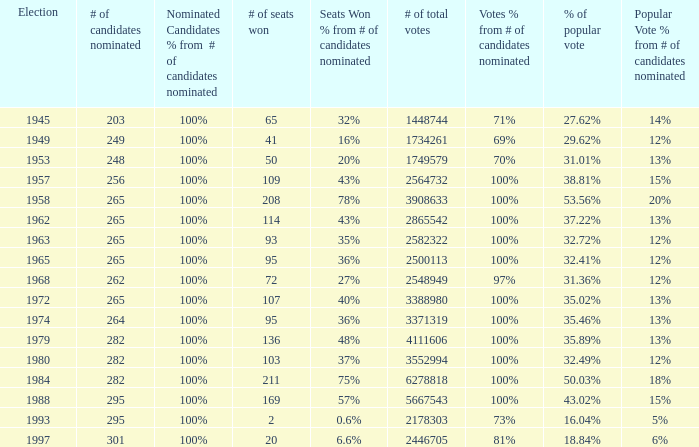What year was the election when the # of seats won was 65? 1945.0. 